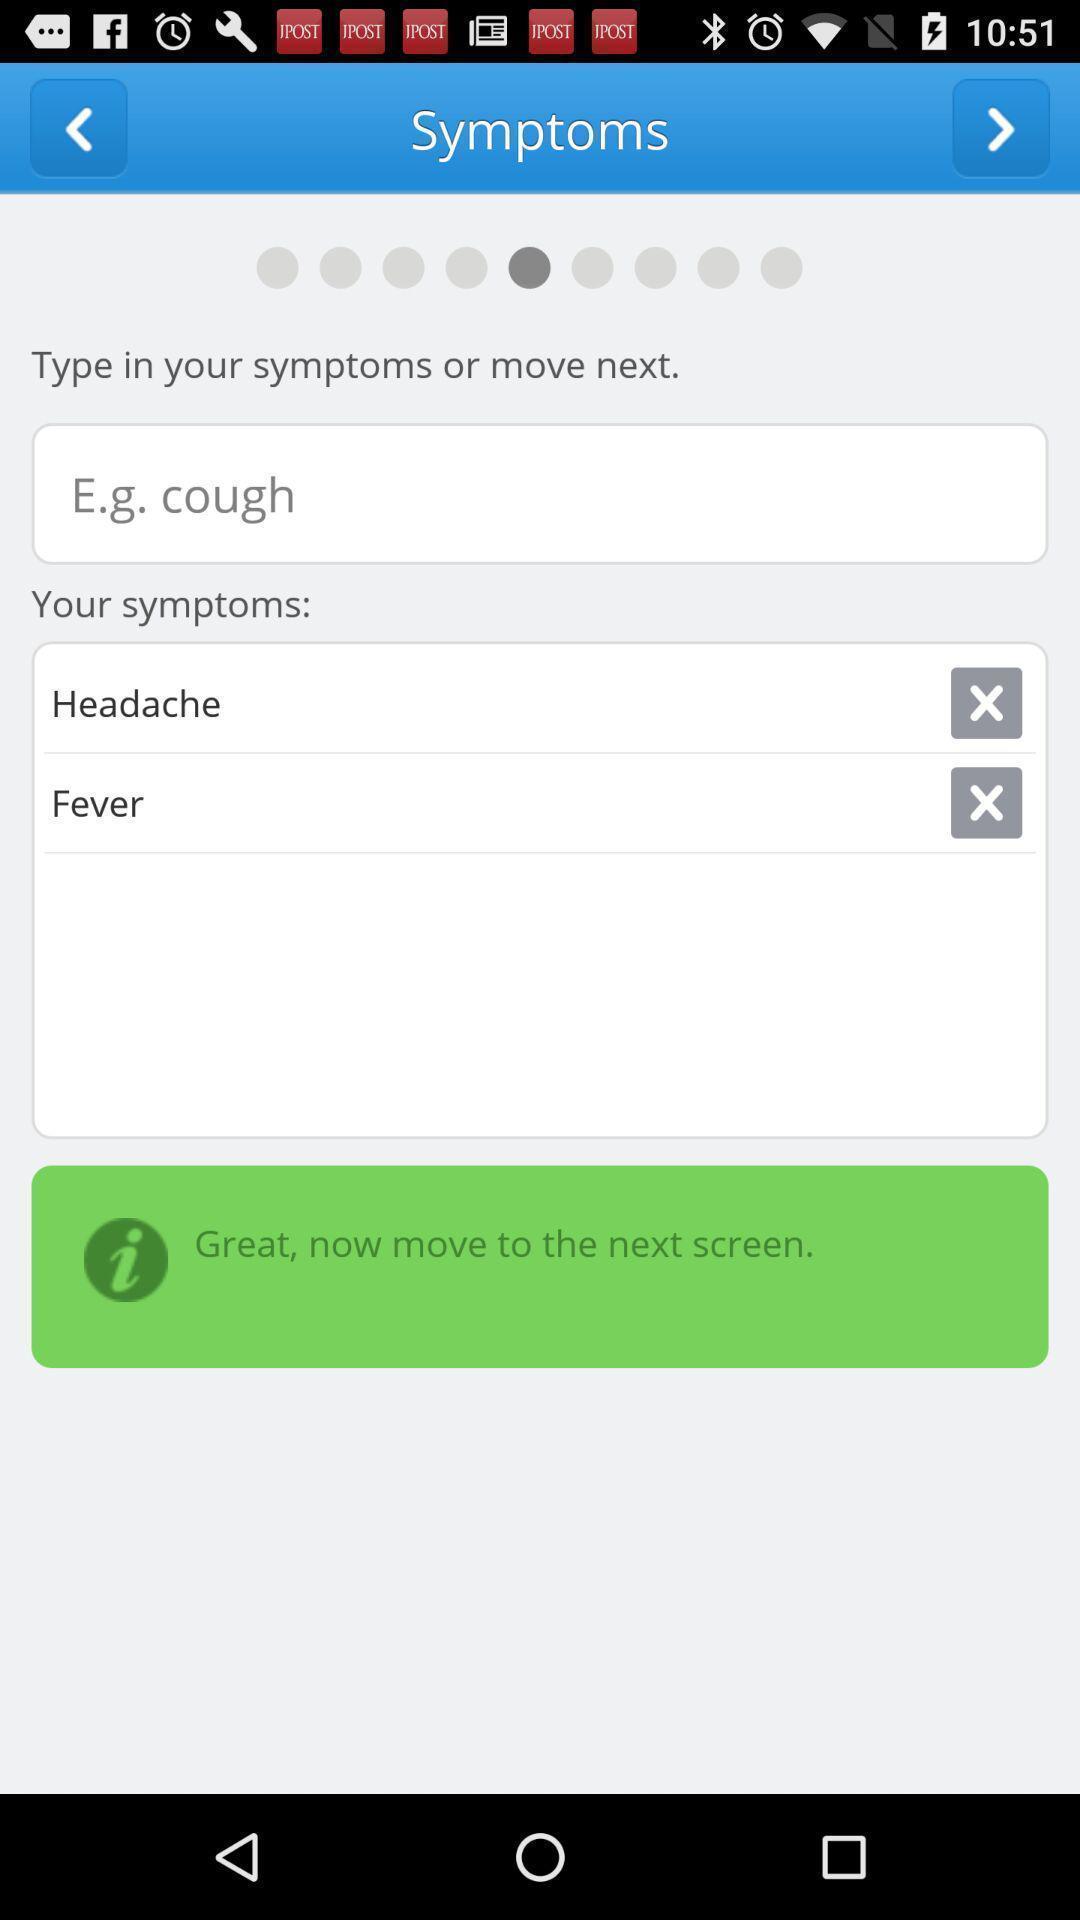Tell me what you see in this picture. Search page for finding your symptoms and move to next. 